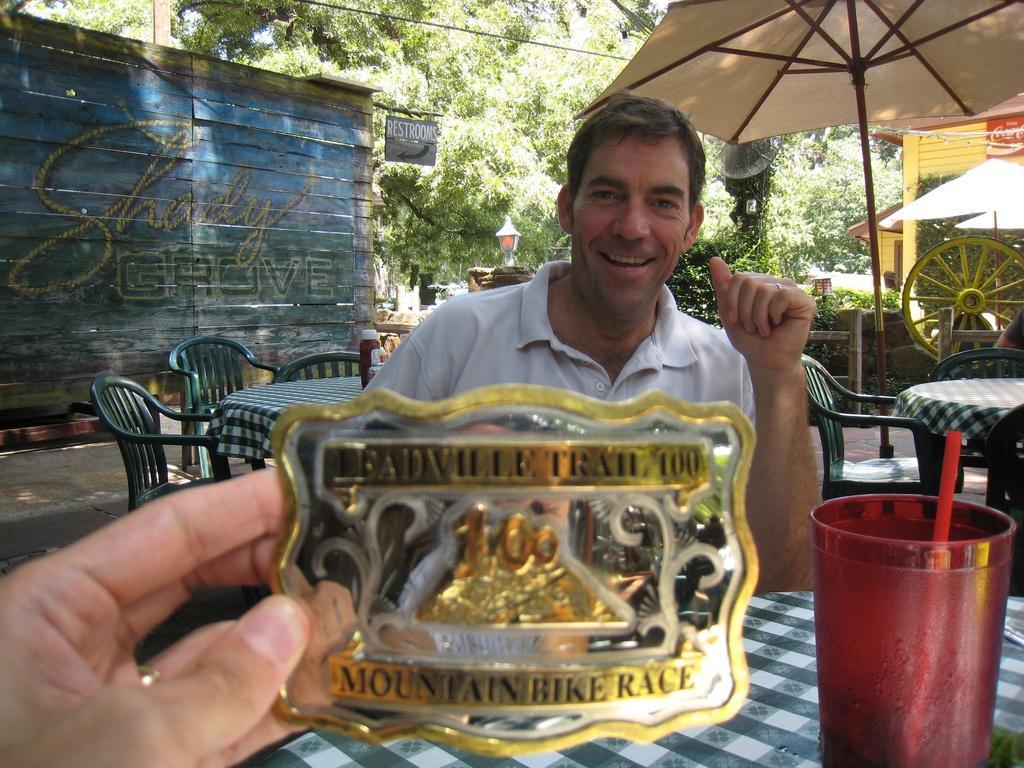Can you describe this image briefly? In this image we can see a man is sitting and smiling, and in front here is the table and and glass and some objects on it, and here is the wall, and here are the trees. 